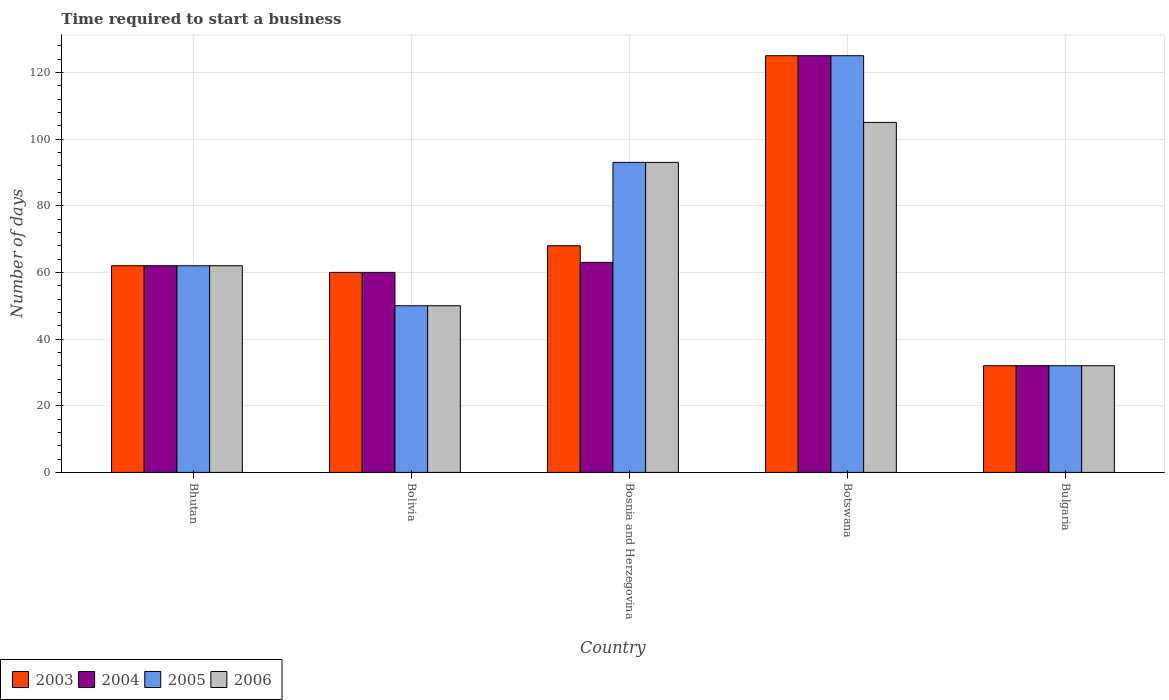Are the number of bars per tick equal to the number of legend labels?
Keep it short and to the point. Yes. What is the label of the 1st group of bars from the left?
Provide a succinct answer. Bhutan. In how many cases, is the number of bars for a given country not equal to the number of legend labels?
Offer a terse response. 0. What is the number of days required to start a business in 2006 in Botswana?
Offer a very short reply. 105. Across all countries, what is the maximum number of days required to start a business in 2005?
Ensure brevity in your answer.  125. In which country was the number of days required to start a business in 2003 maximum?
Provide a short and direct response. Botswana. In which country was the number of days required to start a business in 2004 minimum?
Make the answer very short. Bulgaria. What is the total number of days required to start a business in 2004 in the graph?
Your answer should be compact. 342. What is the difference between the number of days required to start a business in 2006 in Bosnia and Herzegovina and that in Bulgaria?
Give a very brief answer. 61. What is the difference between the number of days required to start a business in 2003 in Botswana and the number of days required to start a business in 2006 in Bosnia and Herzegovina?
Your response must be concise. 32. What is the average number of days required to start a business in 2005 per country?
Offer a terse response. 72.4. What is the difference between the number of days required to start a business of/in 2005 and number of days required to start a business of/in 2004 in Bhutan?
Your response must be concise. 0. In how many countries, is the number of days required to start a business in 2006 greater than 12 days?
Make the answer very short. 5. What is the ratio of the number of days required to start a business in 2004 in Bolivia to that in Botswana?
Offer a terse response. 0.48. Is the number of days required to start a business in 2004 in Bolivia less than that in Bulgaria?
Keep it short and to the point. No. Is the difference between the number of days required to start a business in 2005 in Bolivia and Botswana greater than the difference between the number of days required to start a business in 2004 in Bolivia and Botswana?
Keep it short and to the point. No. In how many countries, is the number of days required to start a business in 2004 greater than the average number of days required to start a business in 2004 taken over all countries?
Provide a succinct answer. 1. Is it the case that in every country, the sum of the number of days required to start a business in 2004 and number of days required to start a business in 2003 is greater than the sum of number of days required to start a business in 2006 and number of days required to start a business in 2005?
Ensure brevity in your answer.  No. What does the 1st bar from the left in Botswana represents?
Your response must be concise. 2003. Is it the case that in every country, the sum of the number of days required to start a business in 2005 and number of days required to start a business in 2006 is greater than the number of days required to start a business in 2003?
Your answer should be very brief. Yes. How many bars are there?
Your answer should be very brief. 20. Are all the bars in the graph horizontal?
Offer a very short reply. No. How many countries are there in the graph?
Your answer should be very brief. 5. Are the values on the major ticks of Y-axis written in scientific E-notation?
Provide a succinct answer. No. Where does the legend appear in the graph?
Give a very brief answer. Bottom left. How many legend labels are there?
Give a very brief answer. 4. What is the title of the graph?
Keep it short and to the point. Time required to start a business. What is the label or title of the X-axis?
Provide a succinct answer. Country. What is the label or title of the Y-axis?
Offer a very short reply. Number of days. What is the Number of days of 2006 in Bhutan?
Your response must be concise. 62. What is the Number of days of 2003 in Bolivia?
Offer a very short reply. 60. What is the Number of days in 2006 in Bolivia?
Provide a short and direct response. 50. What is the Number of days of 2005 in Bosnia and Herzegovina?
Keep it short and to the point. 93. What is the Number of days of 2006 in Bosnia and Herzegovina?
Give a very brief answer. 93. What is the Number of days of 2003 in Botswana?
Your answer should be very brief. 125. What is the Number of days of 2004 in Botswana?
Provide a succinct answer. 125. What is the Number of days in 2005 in Botswana?
Ensure brevity in your answer.  125. What is the Number of days in 2006 in Botswana?
Your answer should be compact. 105. What is the Number of days in 2003 in Bulgaria?
Keep it short and to the point. 32. Across all countries, what is the maximum Number of days in 2003?
Provide a short and direct response. 125. Across all countries, what is the maximum Number of days in 2004?
Your answer should be compact. 125. Across all countries, what is the maximum Number of days of 2005?
Your answer should be very brief. 125. Across all countries, what is the maximum Number of days of 2006?
Make the answer very short. 105. What is the total Number of days of 2003 in the graph?
Ensure brevity in your answer.  347. What is the total Number of days in 2004 in the graph?
Provide a short and direct response. 342. What is the total Number of days of 2005 in the graph?
Offer a terse response. 362. What is the total Number of days in 2006 in the graph?
Ensure brevity in your answer.  342. What is the difference between the Number of days of 2004 in Bhutan and that in Bolivia?
Make the answer very short. 2. What is the difference between the Number of days in 2005 in Bhutan and that in Bolivia?
Offer a terse response. 12. What is the difference between the Number of days of 2006 in Bhutan and that in Bolivia?
Ensure brevity in your answer.  12. What is the difference between the Number of days of 2005 in Bhutan and that in Bosnia and Herzegovina?
Provide a short and direct response. -31. What is the difference between the Number of days in 2006 in Bhutan and that in Bosnia and Herzegovina?
Ensure brevity in your answer.  -31. What is the difference between the Number of days in 2003 in Bhutan and that in Botswana?
Offer a very short reply. -63. What is the difference between the Number of days in 2004 in Bhutan and that in Botswana?
Keep it short and to the point. -63. What is the difference between the Number of days in 2005 in Bhutan and that in Botswana?
Your response must be concise. -63. What is the difference between the Number of days in 2006 in Bhutan and that in Botswana?
Your answer should be very brief. -43. What is the difference between the Number of days of 2003 in Bhutan and that in Bulgaria?
Your response must be concise. 30. What is the difference between the Number of days in 2005 in Bhutan and that in Bulgaria?
Your answer should be compact. 30. What is the difference between the Number of days in 2006 in Bhutan and that in Bulgaria?
Your answer should be very brief. 30. What is the difference between the Number of days in 2005 in Bolivia and that in Bosnia and Herzegovina?
Offer a terse response. -43. What is the difference between the Number of days of 2006 in Bolivia and that in Bosnia and Herzegovina?
Your response must be concise. -43. What is the difference between the Number of days in 2003 in Bolivia and that in Botswana?
Make the answer very short. -65. What is the difference between the Number of days of 2004 in Bolivia and that in Botswana?
Your answer should be very brief. -65. What is the difference between the Number of days of 2005 in Bolivia and that in Botswana?
Keep it short and to the point. -75. What is the difference between the Number of days of 2006 in Bolivia and that in Botswana?
Your answer should be compact. -55. What is the difference between the Number of days in 2005 in Bolivia and that in Bulgaria?
Give a very brief answer. 18. What is the difference between the Number of days in 2006 in Bolivia and that in Bulgaria?
Provide a succinct answer. 18. What is the difference between the Number of days in 2003 in Bosnia and Herzegovina and that in Botswana?
Offer a terse response. -57. What is the difference between the Number of days in 2004 in Bosnia and Herzegovina and that in Botswana?
Your answer should be very brief. -62. What is the difference between the Number of days in 2005 in Bosnia and Herzegovina and that in Botswana?
Your response must be concise. -32. What is the difference between the Number of days in 2006 in Bosnia and Herzegovina and that in Botswana?
Your answer should be very brief. -12. What is the difference between the Number of days in 2004 in Bosnia and Herzegovina and that in Bulgaria?
Your answer should be compact. 31. What is the difference between the Number of days in 2005 in Bosnia and Herzegovina and that in Bulgaria?
Offer a very short reply. 61. What is the difference between the Number of days of 2006 in Bosnia and Herzegovina and that in Bulgaria?
Keep it short and to the point. 61. What is the difference between the Number of days of 2003 in Botswana and that in Bulgaria?
Provide a succinct answer. 93. What is the difference between the Number of days of 2004 in Botswana and that in Bulgaria?
Your response must be concise. 93. What is the difference between the Number of days in 2005 in Botswana and that in Bulgaria?
Your answer should be compact. 93. What is the difference between the Number of days in 2006 in Botswana and that in Bulgaria?
Your answer should be compact. 73. What is the difference between the Number of days of 2003 in Bhutan and the Number of days of 2004 in Bolivia?
Your response must be concise. 2. What is the difference between the Number of days in 2004 in Bhutan and the Number of days in 2006 in Bolivia?
Ensure brevity in your answer.  12. What is the difference between the Number of days in 2003 in Bhutan and the Number of days in 2004 in Bosnia and Herzegovina?
Your answer should be very brief. -1. What is the difference between the Number of days of 2003 in Bhutan and the Number of days of 2005 in Bosnia and Herzegovina?
Provide a succinct answer. -31. What is the difference between the Number of days of 2003 in Bhutan and the Number of days of 2006 in Bosnia and Herzegovina?
Provide a succinct answer. -31. What is the difference between the Number of days of 2004 in Bhutan and the Number of days of 2005 in Bosnia and Herzegovina?
Your answer should be very brief. -31. What is the difference between the Number of days of 2004 in Bhutan and the Number of days of 2006 in Bosnia and Herzegovina?
Offer a very short reply. -31. What is the difference between the Number of days in 2005 in Bhutan and the Number of days in 2006 in Bosnia and Herzegovina?
Your answer should be compact. -31. What is the difference between the Number of days of 2003 in Bhutan and the Number of days of 2004 in Botswana?
Offer a very short reply. -63. What is the difference between the Number of days of 2003 in Bhutan and the Number of days of 2005 in Botswana?
Your answer should be very brief. -63. What is the difference between the Number of days of 2003 in Bhutan and the Number of days of 2006 in Botswana?
Your response must be concise. -43. What is the difference between the Number of days of 2004 in Bhutan and the Number of days of 2005 in Botswana?
Offer a terse response. -63. What is the difference between the Number of days of 2004 in Bhutan and the Number of days of 2006 in Botswana?
Your response must be concise. -43. What is the difference between the Number of days of 2005 in Bhutan and the Number of days of 2006 in Botswana?
Your answer should be very brief. -43. What is the difference between the Number of days in 2003 in Bhutan and the Number of days in 2004 in Bulgaria?
Make the answer very short. 30. What is the difference between the Number of days of 2004 in Bhutan and the Number of days of 2006 in Bulgaria?
Your answer should be compact. 30. What is the difference between the Number of days of 2003 in Bolivia and the Number of days of 2005 in Bosnia and Herzegovina?
Your answer should be very brief. -33. What is the difference between the Number of days in 2003 in Bolivia and the Number of days in 2006 in Bosnia and Herzegovina?
Your answer should be compact. -33. What is the difference between the Number of days in 2004 in Bolivia and the Number of days in 2005 in Bosnia and Herzegovina?
Make the answer very short. -33. What is the difference between the Number of days of 2004 in Bolivia and the Number of days of 2006 in Bosnia and Herzegovina?
Offer a terse response. -33. What is the difference between the Number of days of 2005 in Bolivia and the Number of days of 2006 in Bosnia and Herzegovina?
Offer a very short reply. -43. What is the difference between the Number of days of 2003 in Bolivia and the Number of days of 2004 in Botswana?
Give a very brief answer. -65. What is the difference between the Number of days in 2003 in Bolivia and the Number of days in 2005 in Botswana?
Give a very brief answer. -65. What is the difference between the Number of days in 2003 in Bolivia and the Number of days in 2006 in Botswana?
Ensure brevity in your answer.  -45. What is the difference between the Number of days in 2004 in Bolivia and the Number of days in 2005 in Botswana?
Give a very brief answer. -65. What is the difference between the Number of days in 2004 in Bolivia and the Number of days in 2006 in Botswana?
Your answer should be compact. -45. What is the difference between the Number of days of 2005 in Bolivia and the Number of days of 2006 in Botswana?
Make the answer very short. -55. What is the difference between the Number of days in 2003 in Bolivia and the Number of days in 2004 in Bulgaria?
Give a very brief answer. 28. What is the difference between the Number of days in 2004 in Bolivia and the Number of days in 2006 in Bulgaria?
Keep it short and to the point. 28. What is the difference between the Number of days of 2003 in Bosnia and Herzegovina and the Number of days of 2004 in Botswana?
Provide a short and direct response. -57. What is the difference between the Number of days in 2003 in Bosnia and Herzegovina and the Number of days in 2005 in Botswana?
Make the answer very short. -57. What is the difference between the Number of days of 2003 in Bosnia and Herzegovina and the Number of days of 2006 in Botswana?
Your answer should be compact. -37. What is the difference between the Number of days in 2004 in Bosnia and Herzegovina and the Number of days in 2005 in Botswana?
Make the answer very short. -62. What is the difference between the Number of days of 2004 in Bosnia and Herzegovina and the Number of days of 2006 in Botswana?
Keep it short and to the point. -42. What is the difference between the Number of days of 2005 in Bosnia and Herzegovina and the Number of days of 2006 in Botswana?
Keep it short and to the point. -12. What is the difference between the Number of days of 2003 in Bosnia and Herzegovina and the Number of days of 2005 in Bulgaria?
Keep it short and to the point. 36. What is the difference between the Number of days in 2003 in Botswana and the Number of days in 2004 in Bulgaria?
Offer a terse response. 93. What is the difference between the Number of days of 2003 in Botswana and the Number of days of 2005 in Bulgaria?
Your answer should be very brief. 93. What is the difference between the Number of days in 2003 in Botswana and the Number of days in 2006 in Bulgaria?
Your answer should be compact. 93. What is the difference between the Number of days in 2004 in Botswana and the Number of days in 2005 in Bulgaria?
Offer a terse response. 93. What is the difference between the Number of days in 2004 in Botswana and the Number of days in 2006 in Bulgaria?
Your answer should be very brief. 93. What is the difference between the Number of days in 2005 in Botswana and the Number of days in 2006 in Bulgaria?
Offer a very short reply. 93. What is the average Number of days of 2003 per country?
Provide a short and direct response. 69.4. What is the average Number of days of 2004 per country?
Your answer should be very brief. 68.4. What is the average Number of days in 2005 per country?
Offer a terse response. 72.4. What is the average Number of days in 2006 per country?
Give a very brief answer. 68.4. What is the difference between the Number of days of 2003 and Number of days of 2005 in Bhutan?
Give a very brief answer. 0. What is the difference between the Number of days in 2004 and Number of days in 2005 in Bhutan?
Your answer should be compact. 0. What is the difference between the Number of days in 2003 and Number of days in 2004 in Bolivia?
Provide a short and direct response. 0. What is the difference between the Number of days of 2004 and Number of days of 2006 in Bolivia?
Offer a very short reply. 10. What is the difference between the Number of days of 2003 and Number of days of 2004 in Bosnia and Herzegovina?
Offer a very short reply. 5. What is the difference between the Number of days of 2004 and Number of days of 2005 in Bosnia and Herzegovina?
Provide a short and direct response. -30. What is the difference between the Number of days of 2004 and Number of days of 2006 in Bosnia and Herzegovina?
Offer a very short reply. -30. What is the difference between the Number of days in 2003 and Number of days in 2004 in Botswana?
Offer a terse response. 0. What is the difference between the Number of days of 2003 and Number of days of 2005 in Botswana?
Give a very brief answer. 0. What is the difference between the Number of days of 2003 and Number of days of 2006 in Botswana?
Your response must be concise. 20. What is the difference between the Number of days of 2003 and Number of days of 2005 in Bulgaria?
Give a very brief answer. 0. What is the difference between the Number of days in 2003 and Number of days in 2006 in Bulgaria?
Make the answer very short. 0. What is the difference between the Number of days in 2004 and Number of days in 2005 in Bulgaria?
Make the answer very short. 0. What is the difference between the Number of days of 2004 and Number of days of 2006 in Bulgaria?
Your response must be concise. 0. What is the ratio of the Number of days of 2005 in Bhutan to that in Bolivia?
Your answer should be very brief. 1.24. What is the ratio of the Number of days of 2006 in Bhutan to that in Bolivia?
Offer a very short reply. 1.24. What is the ratio of the Number of days of 2003 in Bhutan to that in Bosnia and Herzegovina?
Your response must be concise. 0.91. What is the ratio of the Number of days of 2004 in Bhutan to that in Bosnia and Herzegovina?
Ensure brevity in your answer.  0.98. What is the ratio of the Number of days in 2005 in Bhutan to that in Bosnia and Herzegovina?
Your answer should be compact. 0.67. What is the ratio of the Number of days of 2003 in Bhutan to that in Botswana?
Offer a terse response. 0.5. What is the ratio of the Number of days of 2004 in Bhutan to that in Botswana?
Provide a short and direct response. 0.5. What is the ratio of the Number of days in 2005 in Bhutan to that in Botswana?
Keep it short and to the point. 0.5. What is the ratio of the Number of days of 2006 in Bhutan to that in Botswana?
Provide a succinct answer. 0.59. What is the ratio of the Number of days in 2003 in Bhutan to that in Bulgaria?
Your answer should be compact. 1.94. What is the ratio of the Number of days in 2004 in Bhutan to that in Bulgaria?
Keep it short and to the point. 1.94. What is the ratio of the Number of days of 2005 in Bhutan to that in Bulgaria?
Offer a terse response. 1.94. What is the ratio of the Number of days of 2006 in Bhutan to that in Bulgaria?
Give a very brief answer. 1.94. What is the ratio of the Number of days of 2003 in Bolivia to that in Bosnia and Herzegovina?
Your answer should be very brief. 0.88. What is the ratio of the Number of days in 2005 in Bolivia to that in Bosnia and Herzegovina?
Ensure brevity in your answer.  0.54. What is the ratio of the Number of days in 2006 in Bolivia to that in Bosnia and Herzegovina?
Your answer should be compact. 0.54. What is the ratio of the Number of days of 2003 in Bolivia to that in Botswana?
Your response must be concise. 0.48. What is the ratio of the Number of days of 2004 in Bolivia to that in Botswana?
Give a very brief answer. 0.48. What is the ratio of the Number of days in 2006 in Bolivia to that in Botswana?
Provide a succinct answer. 0.48. What is the ratio of the Number of days in 2003 in Bolivia to that in Bulgaria?
Make the answer very short. 1.88. What is the ratio of the Number of days in 2004 in Bolivia to that in Bulgaria?
Your response must be concise. 1.88. What is the ratio of the Number of days in 2005 in Bolivia to that in Bulgaria?
Provide a short and direct response. 1.56. What is the ratio of the Number of days of 2006 in Bolivia to that in Bulgaria?
Provide a succinct answer. 1.56. What is the ratio of the Number of days of 2003 in Bosnia and Herzegovina to that in Botswana?
Offer a terse response. 0.54. What is the ratio of the Number of days in 2004 in Bosnia and Herzegovina to that in Botswana?
Your response must be concise. 0.5. What is the ratio of the Number of days of 2005 in Bosnia and Herzegovina to that in Botswana?
Provide a short and direct response. 0.74. What is the ratio of the Number of days in 2006 in Bosnia and Herzegovina to that in Botswana?
Your response must be concise. 0.89. What is the ratio of the Number of days of 2003 in Bosnia and Herzegovina to that in Bulgaria?
Your answer should be very brief. 2.12. What is the ratio of the Number of days in 2004 in Bosnia and Herzegovina to that in Bulgaria?
Your answer should be compact. 1.97. What is the ratio of the Number of days of 2005 in Bosnia and Herzegovina to that in Bulgaria?
Keep it short and to the point. 2.91. What is the ratio of the Number of days of 2006 in Bosnia and Herzegovina to that in Bulgaria?
Ensure brevity in your answer.  2.91. What is the ratio of the Number of days in 2003 in Botswana to that in Bulgaria?
Provide a succinct answer. 3.91. What is the ratio of the Number of days of 2004 in Botswana to that in Bulgaria?
Keep it short and to the point. 3.91. What is the ratio of the Number of days in 2005 in Botswana to that in Bulgaria?
Your answer should be very brief. 3.91. What is the ratio of the Number of days of 2006 in Botswana to that in Bulgaria?
Make the answer very short. 3.28. What is the difference between the highest and the lowest Number of days in 2003?
Offer a terse response. 93. What is the difference between the highest and the lowest Number of days in 2004?
Offer a terse response. 93. What is the difference between the highest and the lowest Number of days of 2005?
Keep it short and to the point. 93. What is the difference between the highest and the lowest Number of days of 2006?
Offer a very short reply. 73. 